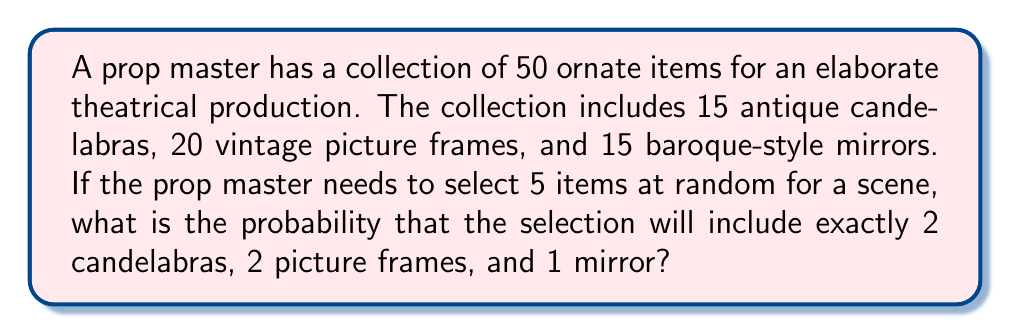Teach me how to tackle this problem. To solve this problem, we'll use the concept of hypergeometric distribution and the multiplication principle of probability.

1) First, we need to calculate the probability of selecting each type of item:

   a) Probability of selecting 2 candelabras out of 15 from a total of 50 items:
      $$P(\text{2 candelabras}) = \frac{\binom{15}{2}}{\binom{50}{2}}$$

   b) Probability of selecting 2 picture frames out of 20 from the remaining 48 items:
      $$P(\text{2 frames}) = \frac{\binom{20}{2}}{\binom{48}{2}}$$

   c) Probability of selecting 1 mirror out of 15 from the remaining 46 items:
      $$P(\text{1 mirror}) = \frac{\binom{15}{1}}{\binom{46}{1}}$$

2) Now, we multiply these probabilities together:

   $$P(\text{2 candelabras, 2 frames, 1 mirror}) = \frac{\binom{15}{2}}{\binom{50}{2}} \cdot \frac{\binom{20}{2}}{\binom{48}{2}} \cdot \frac{\binom{15}{1}}{\binom{46}{1}}$$

3) Let's calculate each part:
   
   $$\frac{\binom{15}{2}}{\binom{50}{2}} = \frac{105}{1225} = \frac{21}{245}$$
   
   $$\frac{\binom{20}{2}}{\binom{48}{2}} = \frac{190}{1128} = \frac{95}{564}$$
   
   $$\frac{\binom{15}{1}}{\binom{46}{1}} = \frac{15}{46}$$

4) Multiplying these together:

   $$\frac{21}{245} \cdot \frac{95}{564} \cdot \frac{15}{46} = \frac{29925}{6370120} \approx 0.0047$$

Therefore, the probability is approximately 0.0047 or about 0.47%.
Answer: $\frac{29925}{6370120} \approx 0.0047$ or approximately 0.47% 